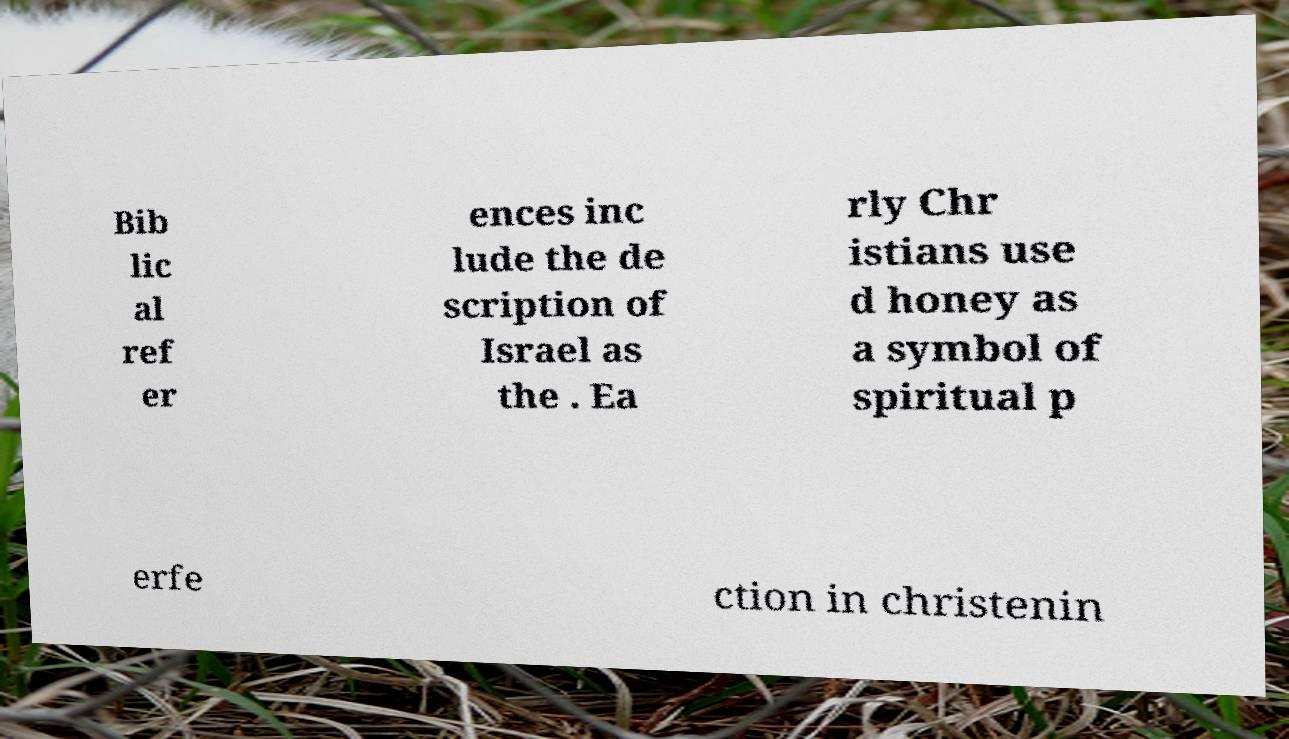Can you read and provide the text displayed in the image?This photo seems to have some interesting text. Can you extract and type it out for me? Bib lic al ref er ences inc lude the de scription of Israel as the . Ea rly Chr istians use d honey as a symbol of spiritual p erfe ction in christenin 